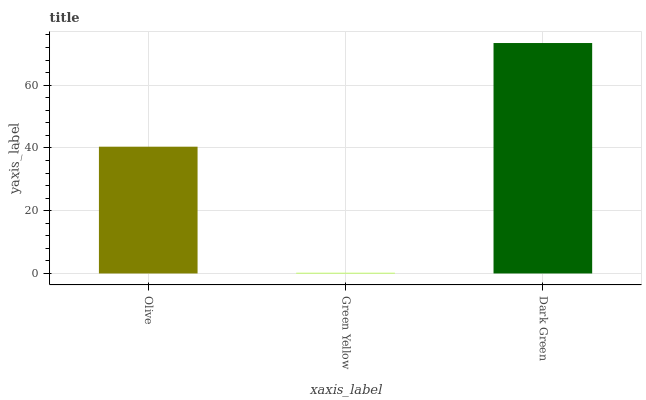Is Green Yellow the minimum?
Answer yes or no. Yes. Is Dark Green the maximum?
Answer yes or no. Yes. Is Dark Green the minimum?
Answer yes or no. No. Is Green Yellow the maximum?
Answer yes or no. No. Is Dark Green greater than Green Yellow?
Answer yes or no. Yes. Is Green Yellow less than Dark Green?
Answer yes or no. Yes. Is Green Yellow greater than Dark Green?
Answer yes or no. No. Is Dark Green less than Green Yellow?
Answer yes or no. No. Is Olive the high median?
Answer yes or no. Yes. Is Olive the low median?
Answer yes or no. Yes. Is Dark Green the high median?
Answer yes or no. No. Is Dark Green the low median?
Answer yes or no. No. 